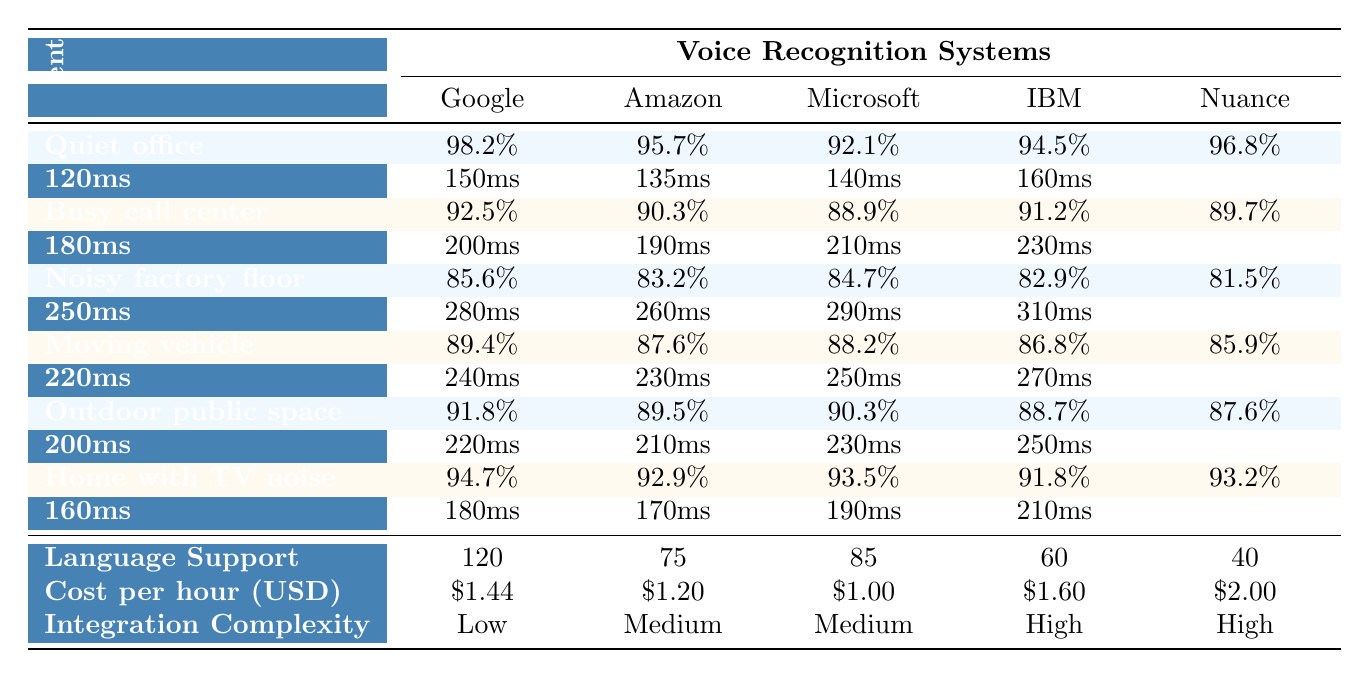What is the accuracy rate of Google Cloud Speech-to-Text in a quiet office? According to the table, the accuracy rate of Google Cloud Speech-to-Text in a quiet office is listed as 98.2%.
Answer: 98.2% Which voice recognition system has the lowest accuracy in a noisy factory floor? The table shows that Nuance Dragon NaturallySpeaking has the lowest accuracy rate of 81.5% in a noisy factory floor environment.
Answer: Nuance Dragon NaturallySpeaking What is the average processing time across all voice recognition systems in a busy call center? The processing times for the busy call center are 180ms, 200ms, 190ms, 210ms, and 230ms. Adding these yields 1000ms and dividing by 5 results in an average of 200ms.
Answer: 200ms Which environment has the highest accuracy for Amazon Transcribe? Reviewing the accuracies for Amazon Transcribe across the environments, the highest accuracy is in the quiet office at 95.7%.
Answer: Quiet office How does the integration complexity differ among the various systems? All voice recognition systems have a similar level of integration complexity, ranging from Low to High. Specifically, Google Cloud, Amazon, Microsoft, IBM, and Nuance all have Low complexity for three out of the five categories, while Medium and High are consistent across the board.
Answer: Similar complexity levels What is the difference in accuracy between Microsoft Azure Speech to Text in a moving vehicle and outdoor public space? The accuracy for Microsoft Azure in a moving vehicle is 88.2%, and in an outdoor public space it is 90.3%. The difference is calculated by subtracting the moving vehicle accuracy from the outdoor public space accuracy, yielding 90.3% - 88.2% = 2.1%.
Answer: 2.1% Is the processing time for Nuance Dragon NaturallySpeaking generally higher or lower than that of Google Cloud Speech-to-Text? By comparing the processing times, Nuance has processing times of 160ms, 230ms, 310ms, 270ms, 250ms, and 210ms, which are generally higher (the lowest being 210ms) compared to Google's lower range of 120ms to 160ms. Thus, Nuance's processing time is generally higher.
Answer: Higher What would be the cost for using IBM Watson Speech to Text for 10 hours? The cost per hour for IBM Watson is $1.60. Therefore, for 10 hours, the total cost would be $1.60 * 10 = $16.00.
Answer: $16.00 Which system performs best in outdoor public space and how does its accuracy rate compare to that of the noisiest environment? The best-performing system in an outdoor public space is Google Cloud Speech-to-Text with an accuracy of 91.8%. In the noisiest environment (the noisy factory floor), the best accuracy is still lower at 85.6%. Hence, the comparison shows a difference of 6.2%.
Answer: 91.8% vs. 85.6% What is the total language support available across all voice recognition systems? Each of the systems supports 120 languages, as listed across all environments. Therefore, the total language support remains 120 languages, without variance by system.
Answer: 120 languages 